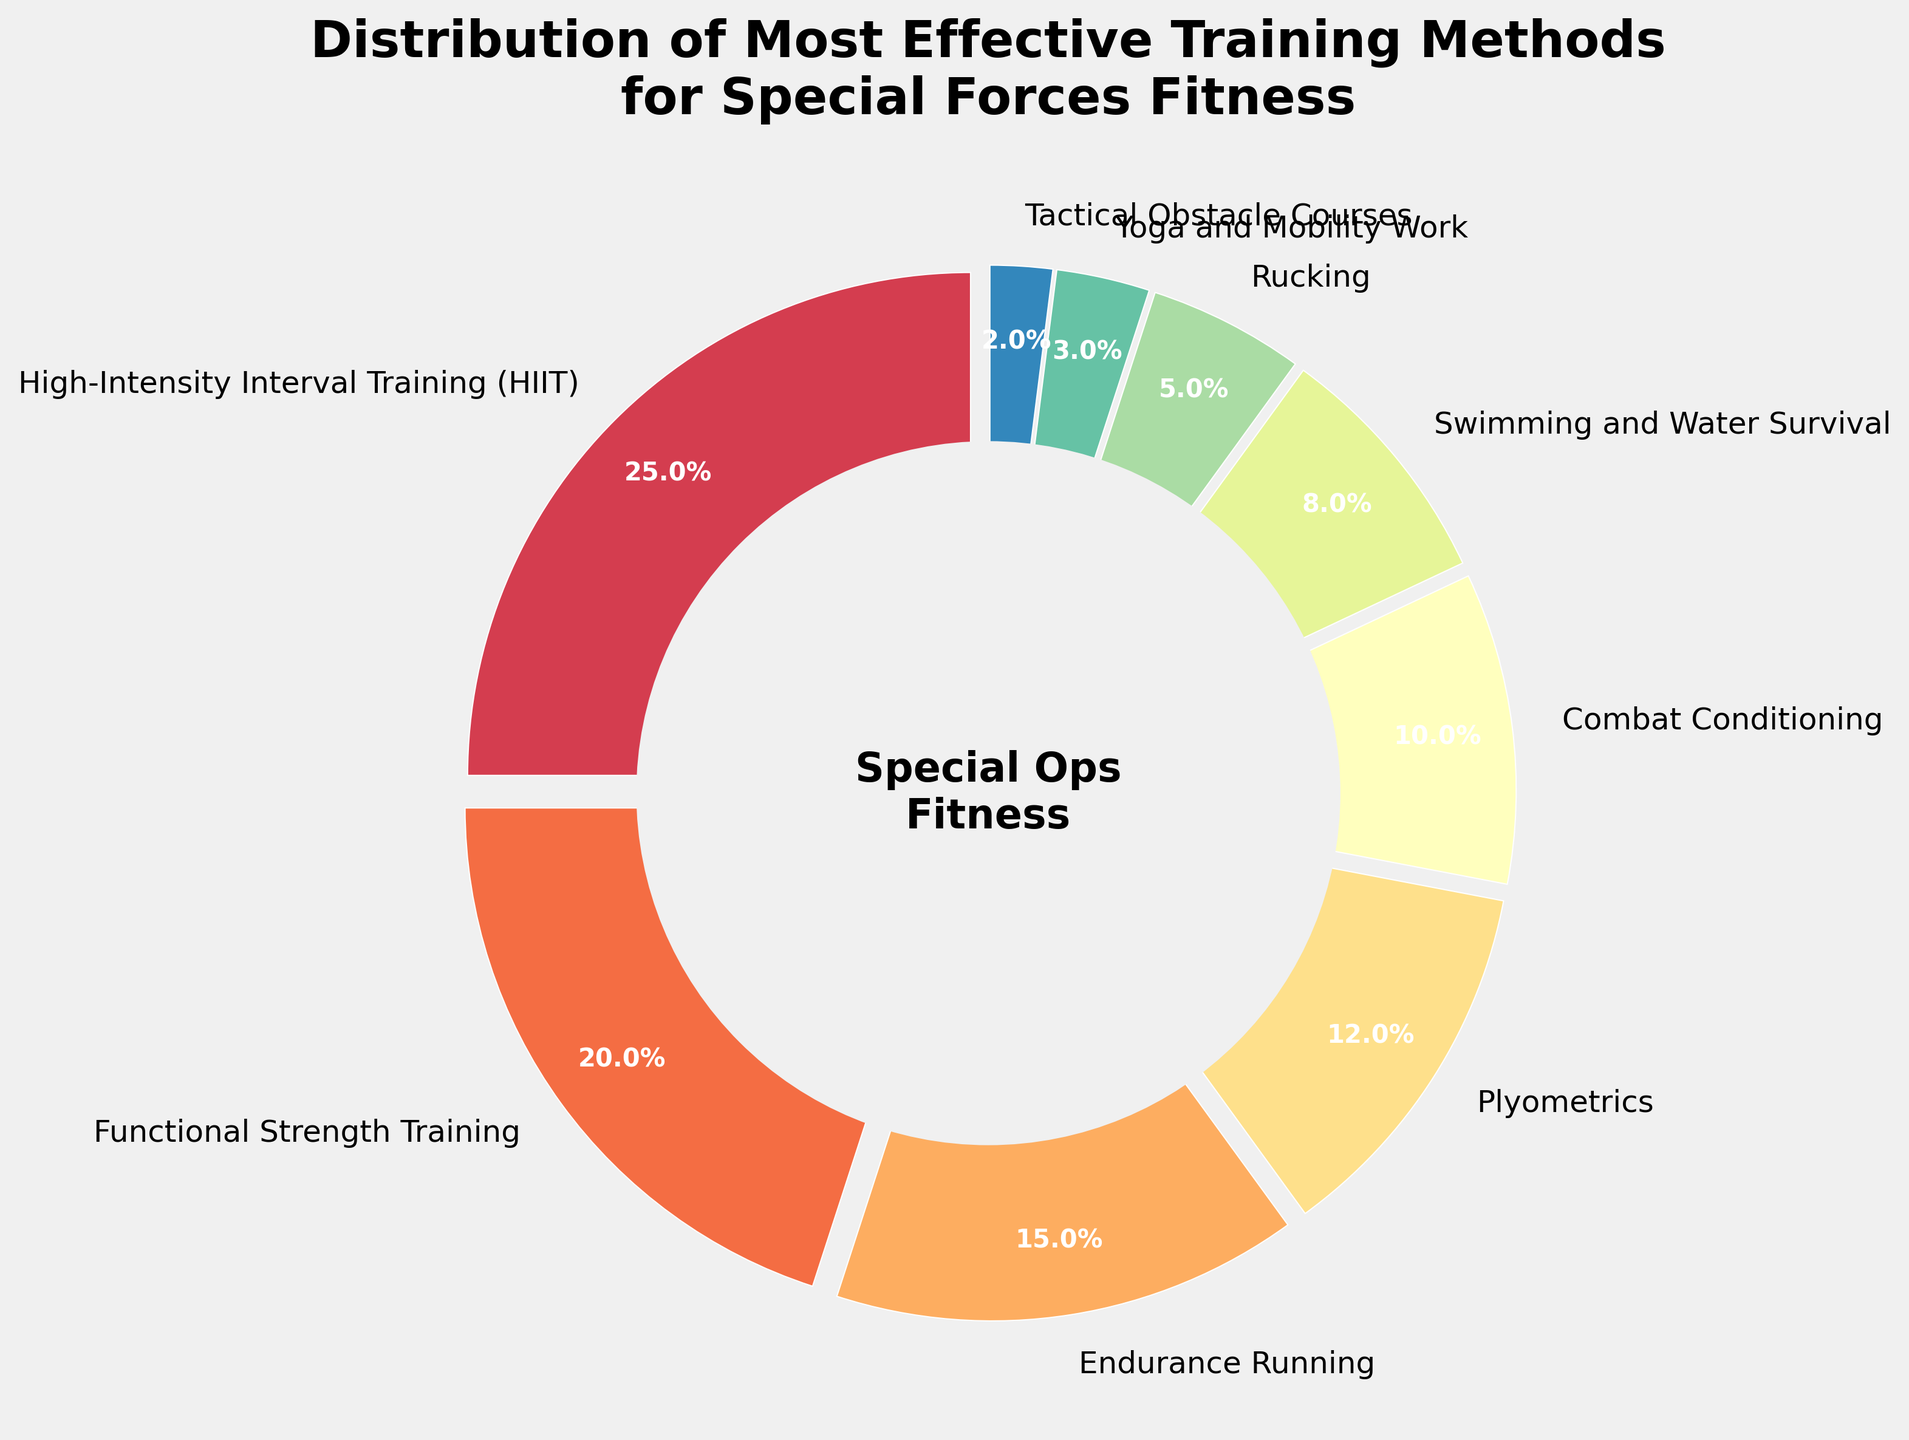What training method has the highest percentage in the distribution? The largest segment in the pie chart represents High-Intensity Interval Training (HIIT), which is marked with 25%.
Answer: HIIT Which training method has the smallest percentage in the distribution? The smallest segment in the pie chart represents Tactical Obstacle Courses, which is marked with 2%.
Answer: Tactical Obstacle Courses What is the combined percentage of Plyometrics and Combat Conditioning? From the chart, Plyometrics is 12% and Combat Conditioning is 10%. Adding them together, 12% + 10% = 22%.
Answer: 22% Which has a larger percentage, Swimming and Water Survival or Rucking? The pie chart shows that Swimming and Water Survival is 8%, while Rucking is 5%. Therefore, Swimming and Water Survival has a larger percentage.
Answer: Swimming and Water Survival What is the total percentage of all the training methods having a percentage below 10% each? From the chart, the methods below 10% are Combat Conditioning (10%), Swimming and Water Survival (8%), Rucking (5%), Yoga and Mobility Work (3%), and Tactical Obstacle Courses (2%). Adding these, 10% + 8% + 5% + 3% + 2% = 28%.
Answer: 28% What training methods contribute to more than 20% of the distribution? The pie chart shows High-Intensity Interval Training (HIIT) at 25%. This method is the only one above 20%.
Answer: HIIT Which training method is the closest in percentage to Yoga and Mobility Work? The pie chart indicates that Yoga and Mobility Work is 3%, just below Rucking which is 5%, making Rucking the closest in percentage.
Answer: Rucking What percentage of the training methods consists of Functional Strength Training and Endurance Running combined? From the chart, Functional Strength Training is 20% and Endurance Running is 15%. Adding them together, 20% + 15% = 35%.
Answer: 35% Are there more training methods with a percentage higher than 15% or lower than 15%? The pie chart shows three methods higher than 15%: High-Intensity Interval Training (25%), Functional Strength Training (20%), and Endurance Running (15%). There are six methods below 15%: Plyometrics (12%), Combat Conditioning (10%), Swimming and Water Survival (8%), Rucking (5%), Yoga and Mobility Work (3%), and Tactical Obstacle Courses (2%). As a result, there are more training methods with a percentage lower than 15%.
Answer: Lower than 15% Is the sum of the percentages for Functional Strength Training and Plyometrics greater than that of Endurance Running and Combat Conditioning combined? Functional Strength Training is 20% and Plyometrics is 12%, making their sum 32%. Endurance Running is 15% and Combat Conditioning is 10%, making their sum 25%. Comparing the sums, 32% is greater than 25%.
Answer: Yes 